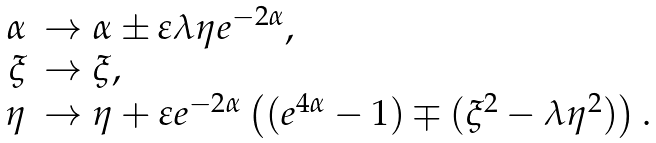Convert formula to latex. <formula><loc_0><loc_0><loc_500><loc_500>\begin{array} { r l } \alpha & \rightarrow \alpha \pm \varepsilon \lambda \eta e ^ { - 2 \alpha } , \\ \xi & \rightarrow \xi , \\ \eta & \rightarrow \eta + \varepsilon e ^ { - 2 \alpha } \left ( ( e ^ { 4 \alpha } - 1 ) \mp ( \xi ^ { 2 } - \lambda \eta ^ { 2 } ) \right ) . \end{array}</formula> 